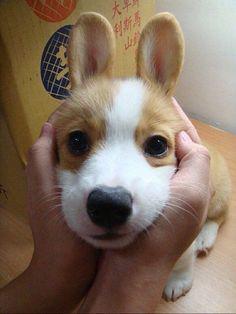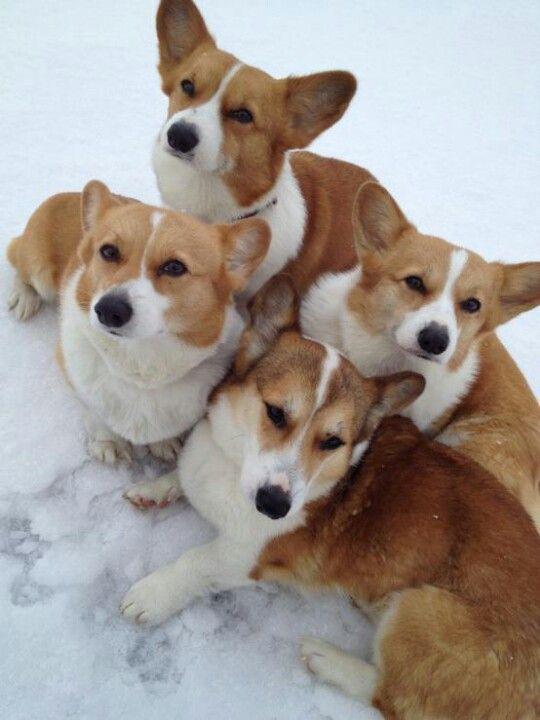The first image is the image on the left, the second image is the image on the right. Evaluate the accuracy of this statement regarding the images: "There are more than four dogs.". Is it true? Answer yes or no. Yes. The first image is the image on the left, the second image is the image on the right. Analyze the images presented: Is the assertion "At least one hand is touching a dog, and at least one image contains a single dog with upright ears." valid? Answer yes or no. Yes. 